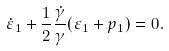<formula> <loc_0><loc_0><loc_500><loc_500>\dot { \varepsilon } _ { 1 } + \frac { 1 } { 2 } \frac { \dot { \gamma } } { \gamma } ( \varepsilon _ { 1 } + p _ { 1 } ) = 0 .</formula> 